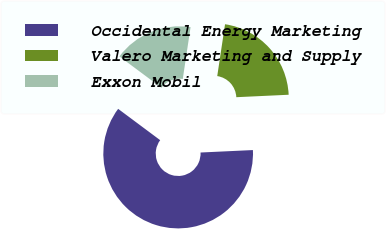Convert chart to OTSL. <chart><loc_0><loc_0><loc_500><loc_500><pie_chart><fcel>Occidental Energy Marketing<fcel>Valero Marketing and Supply<fcel>Exxon Mobil<nl><fcel>60.94%<fcel>21.88%<fcel>17.19%<nl></chart> 